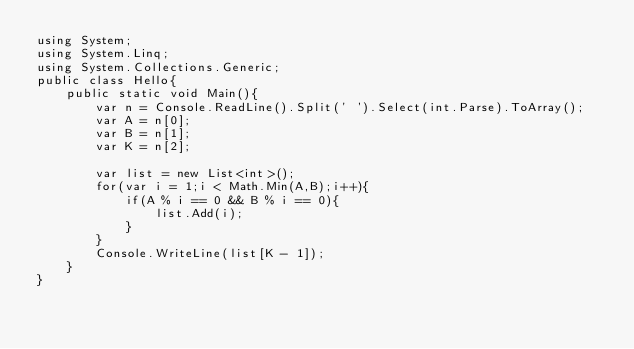Convert code to text. <code><loc_0><loc_0><loc_500><loc_500><_C#_>using System;
using System.Linq;
using System.Collections.Generic;
public class Hello{
    public static void Main(){
        var n = Console.ReadLine().Split(' ').Select(int.Parse).ToArray();
        var A = n[0];
        var B = n[1];
        var K = n[2];
        
        var list = new List<int>();
        for(var i = 1;i < Math.Min(A,B);i++){
            if(A % i == 0 && B % i == 0){
                list.Add(i);
            }
        }
        Console.WriteLine(list[K - 1]);
    }
}
</code> 